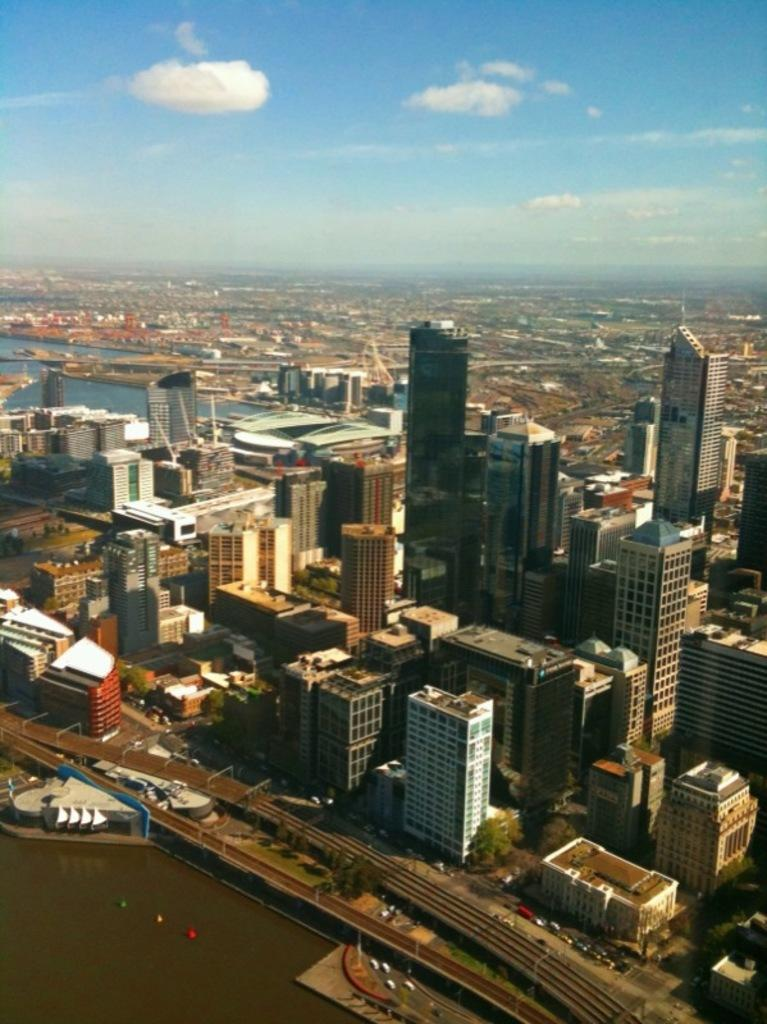What type of location is depicted in the image? The image is of a city. What natural element can be seen in the image? There is water in the image. What type of structures are present in the city? Skyscrapers and other buildings are visible in the image. How do people and vehicles move around in the city? Roads are in the image, which allow for movement. What is visible in the sky in the image? The sky is visible in the image. What type of dish is being cooked in the image? There is no dish or cooking activity present in the image; it depicts a city with various elements like water, skyscrapers, buildings, roads, and the sky. 